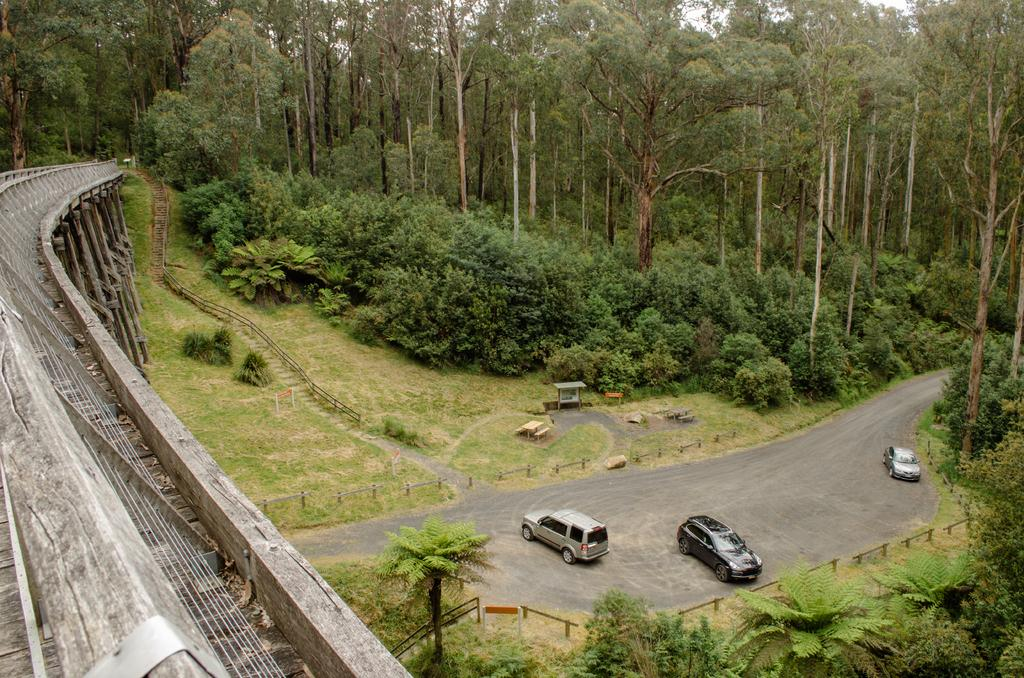What structure is located on the left side of the image? There is a bridge on the left side of the image. What can be seen at the bottom of the image? There are cars on the road at the bottom of the image. What type of barrier is visible in the image? There is a fence visible in the image. What type of vegetation is in the background of the image? There are trees in the background of the image. What architectural feature can be seen in the background of the image? There are stairs in the background of the image. What is visible in the background of the image? The sky is visible in the background of the image. What type of breakfast is being served on the bridge in the image? There is no breakfast present in the image; it features a bridge, cars, a fence, trees, stairs, and the sky. Can you see any dinosaurs walking on the bridge in the image? There are no dinosaurs present in the image; it features a bridge, cars, a fence, trees, stairs, and the sky. 